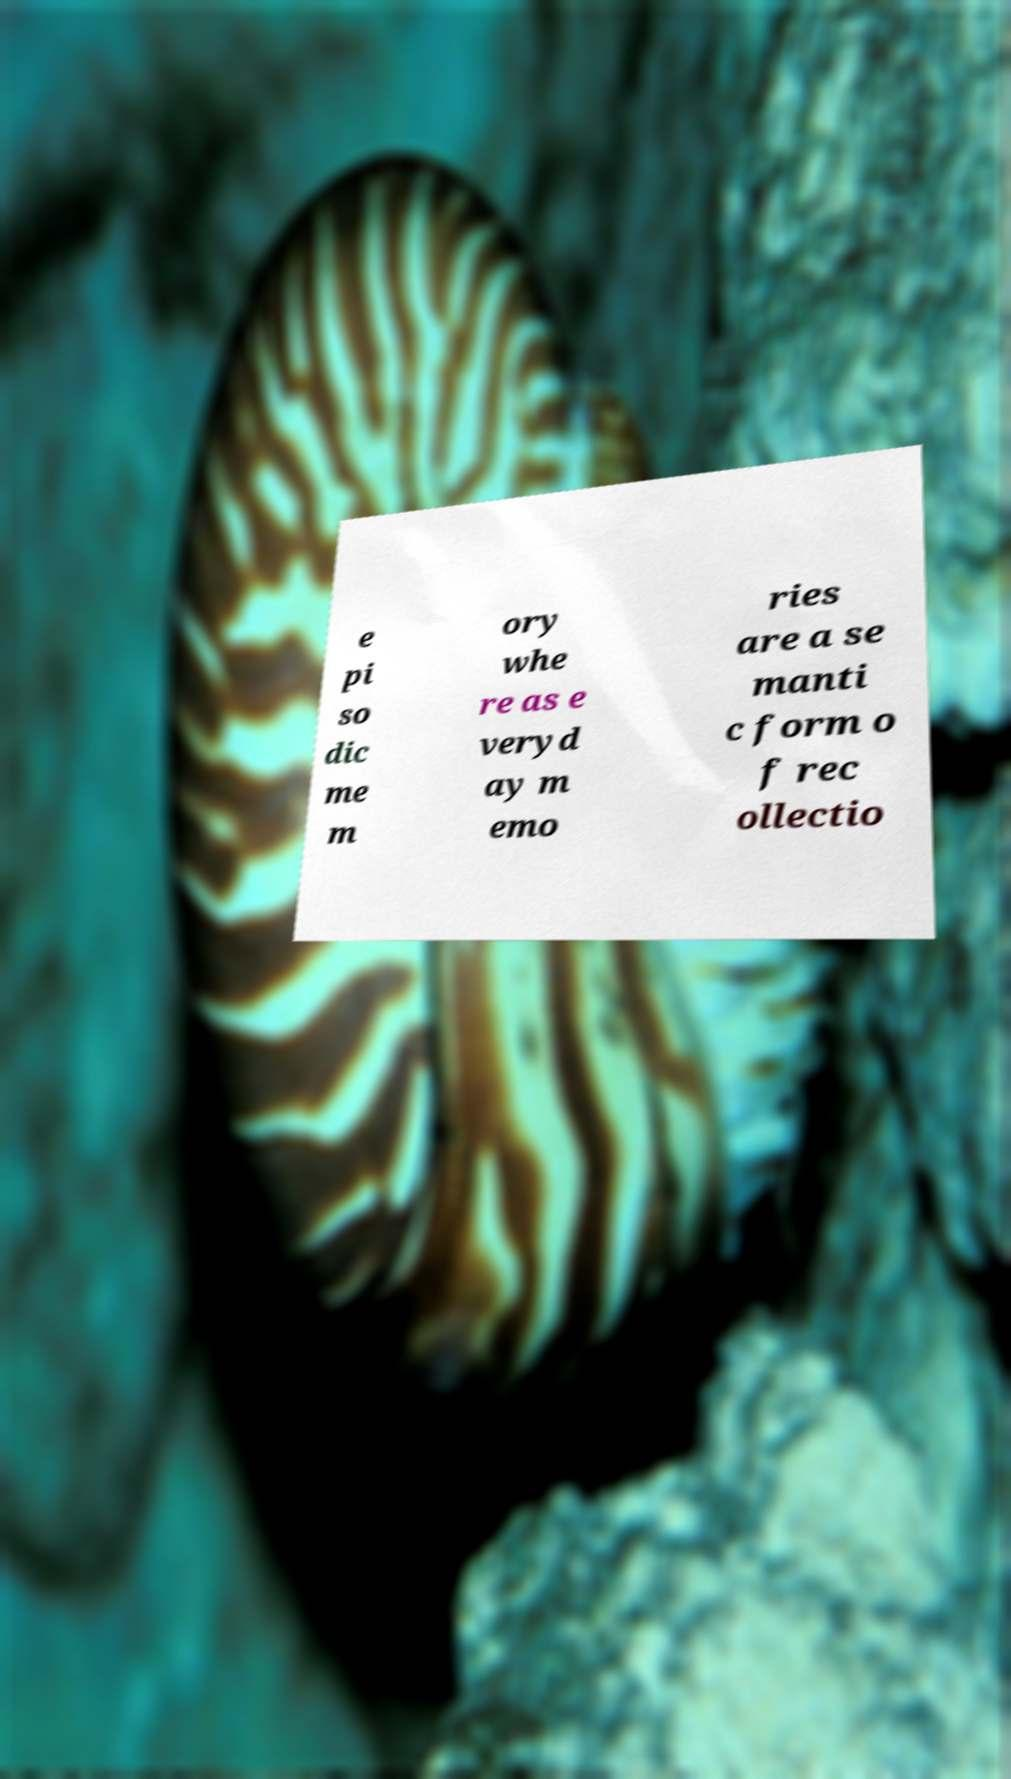Please read and relay the text visible in this image. What does it say? e pi so dic me m ory whe re as e veryd ay m emo ries are a se manti c form o f rec ollectio 